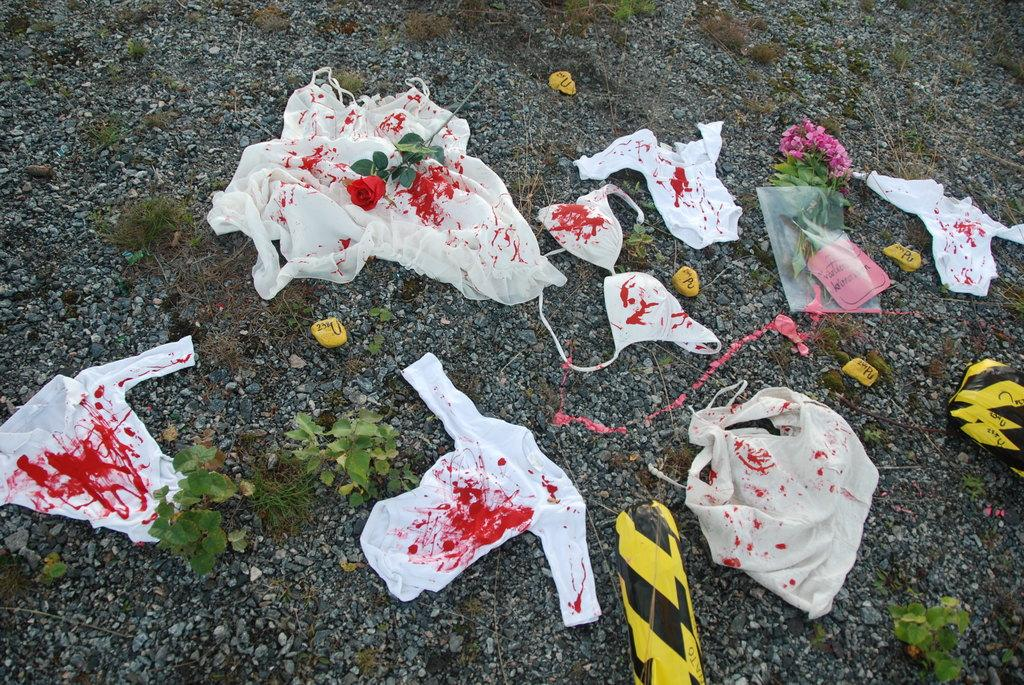What type of vegetation can be seen on the ground in the image? There are plants on the ground in the image. What else can be found on the ground besides plants? There are stones on the ground in the image. What can be observed about the clothes in the image? The clothes have colors. What specific type of flower is present on the cloth? There is a rose flower with a stem on the cloth. What is contained within the packet in the image? The packet contains flowers. Can you describe the locket that is hanging from the sleet in the image? There is no locket or sleet present in the image. What type of rub is being used to polish the stones in the image? There is no rubbing or polishing activity depicted in the image. 